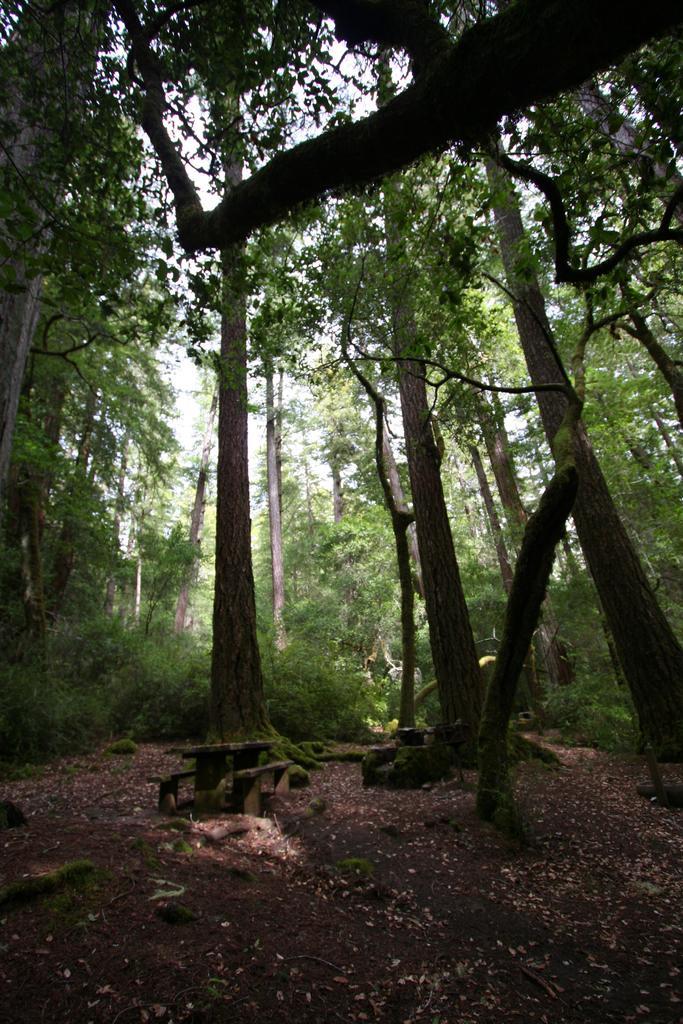Can you describe this image briefly? We can see trees,plants and sky. 